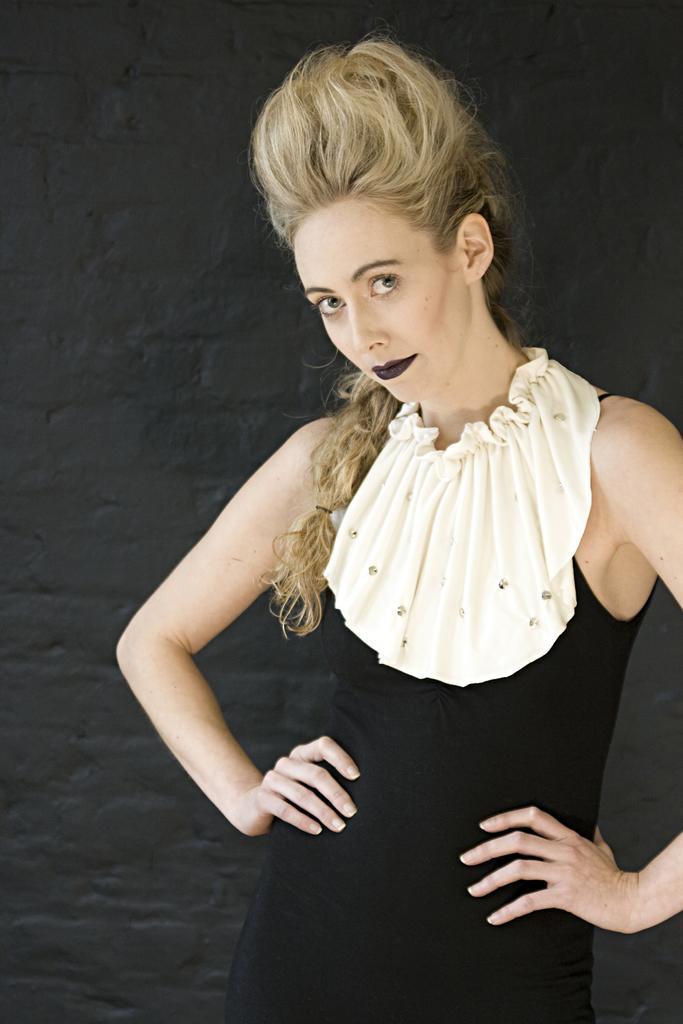Could you give a brief overview of what you see in this image? In this picture I can see a girl standing, and in the background there is a wall. 